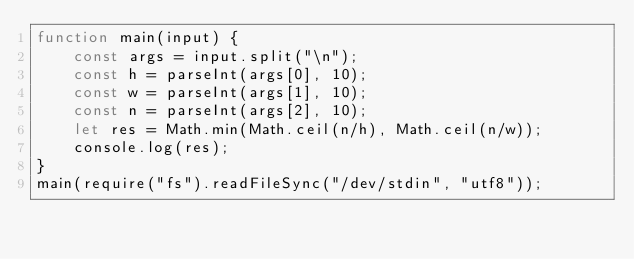Convert code to text. <code><loc_0><loc_0><loc_500><loc_500><_JavaScript_>function main(input) {
    const args = input.split("\n");
    const h = parseInt(args[0], 10);
    const w = parseInt(args[1], 10);
    const n = parseInt(args[2], 10);
    let res = Math.min(Math.ceil(n/h), Math.ceil(n/w));
    console.log(res);
}
main(require("fs").readFileSync("/dev/stdin", "utf8"));</code> 